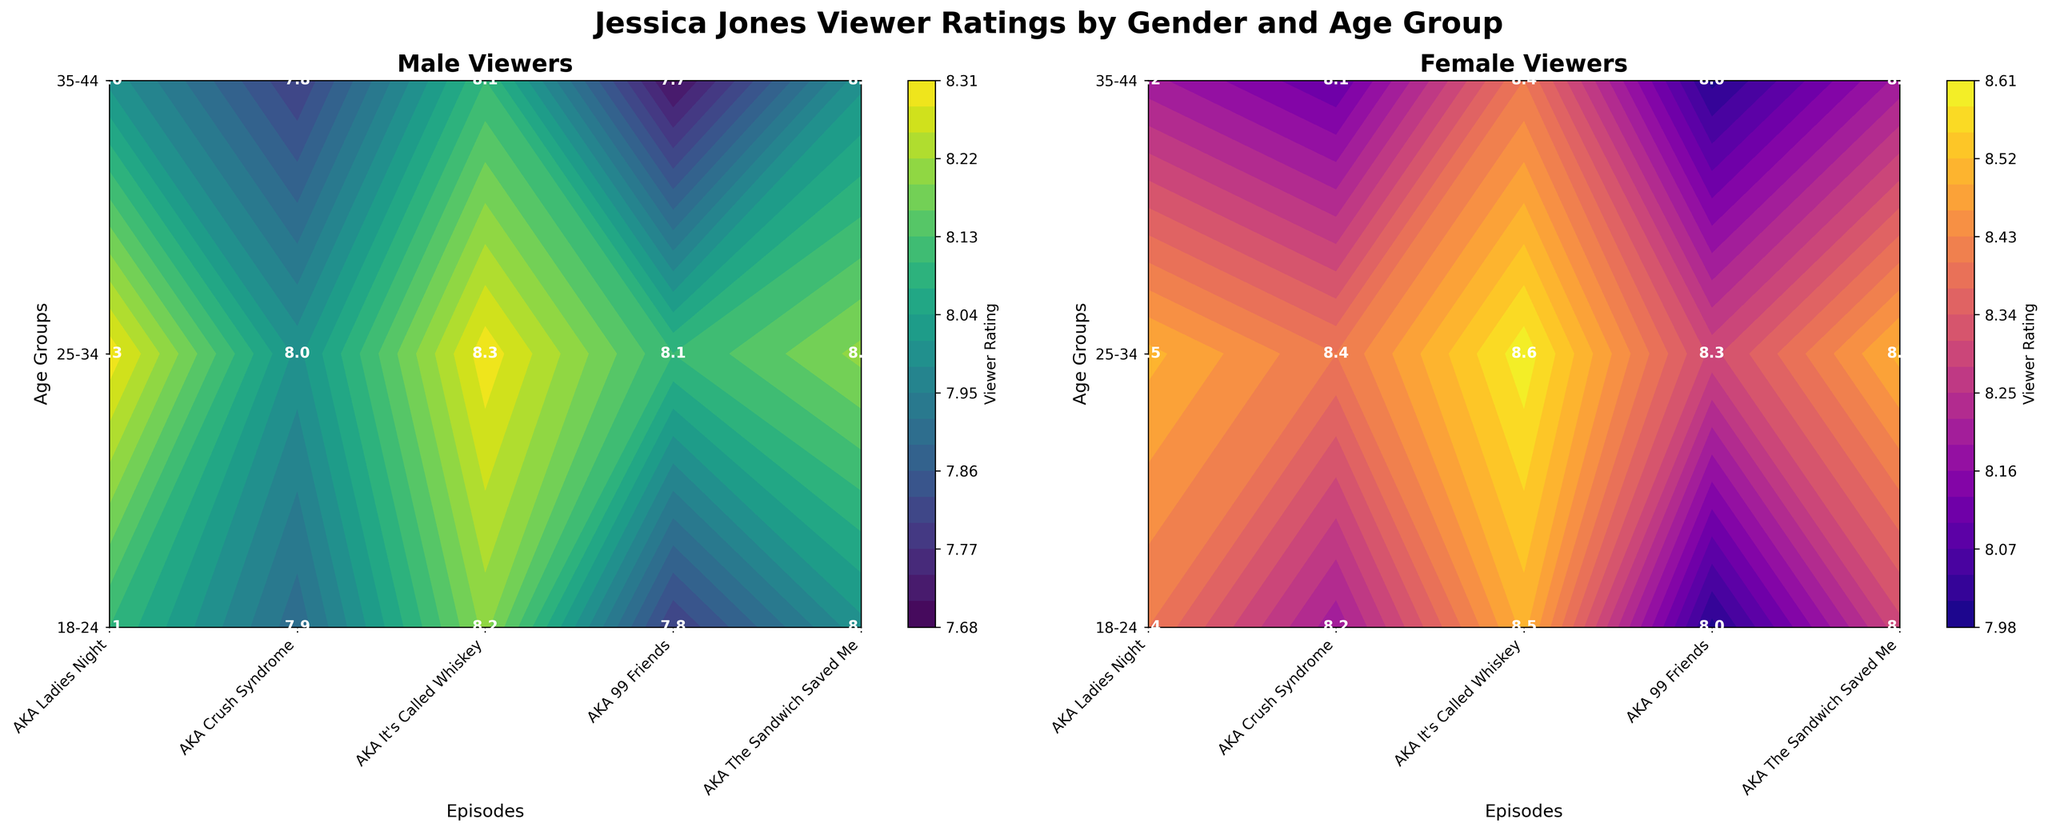What is the highest viewer rating for male viewers? Look at the contour plot for male viewers, identify the highest rating marked on the plot.
Answer: 8.3 What age group gave the highest viewer rating to "AKA It's Called Whiskey"? Referring to both contour plots, pinpoint the highest rating for the episode "AKA It's Called Whiskey" for both genders, and note the highest age group.
Answer: 25-34 Which episode received the lowest rating from the 35-44 age group for female viewers? Check the female viewers' contour plot and find the episode with the lowest rating for the 35-44 age group.
Answer: AKA 99 Friends What's the average viewer rating across all episodes for the 18-24 age group? Add the ratings for all episodes for the 18-24 age group conbined for both genders, then divide by the total number of ratings. (8.1+8.4+7.9+8.2+8.2+8.5+8.0+8.2 = 66.6) / 8 = 8.325
Answer: 8.3 Which episode shows the biggest difference in ratings between male and female viewers aged 18-24? For each episode, compute the absolute difference in ratings between male and female viewers within the 18-24 age group and identify the maximum difference.
Answer: AKA Crush Syndrome How do the viewer ratings for “AKA The Sandwich Saved Me” compare between 25-34 males and 35-44 females? Compare the contour plot values for the viewer ratings of 25-34 males and 35-44 females for the episode “AKA The Sandwich Saved Me”.
Answer: 25-34 males rated it 8.2, while 35-44 females rated it 8.2 What trend do you observe in male viewer ratings as the age group increases for "AKA Ladies Night"? Check the male viewer ratings for "AKA Ladies Night" across the different age groups (18-24, 25-34, 35-44) and describe the trend.
Answer: The rating decreases with increasing age group from 8.1 to 8.0 Which gender gave consistently higher ratings for "AKA Crush Syndrome"? Compare the male and female ratings for "AKA Crush Syndrome" across all age groups and identify the one with consistently higher ratings.
Answer: Female Are the ratings for "AKA It's Called Whiskey" similar or different across genders? Check the ratings for both male and female viewers for "AKA It's Called Whiskey" and compare them for each age group.
Answer: Similar, with females giving slightly higher ratings Considering only the female viewers, which age group showed the greatest variation in ratings across all episodes? Analyze the range of ratings for each age group among female viewers and identify the one with the largest variation (difference between highest and lowest ratings).
Answer: 25-34 